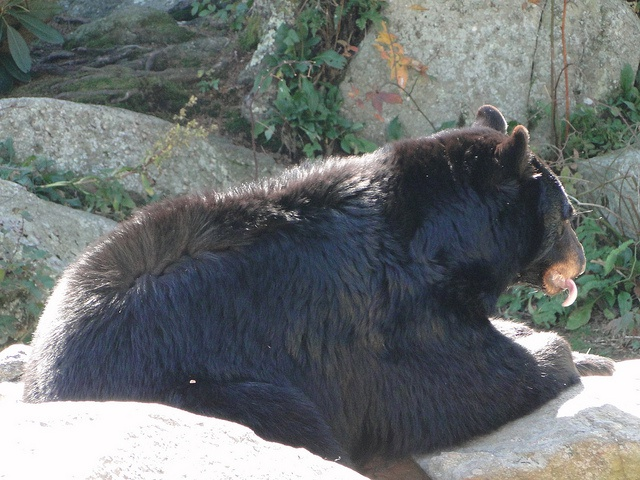Describe the objects in this image and their specific colors. I can see a bear in gray, black, and darkblue tones in this image. 